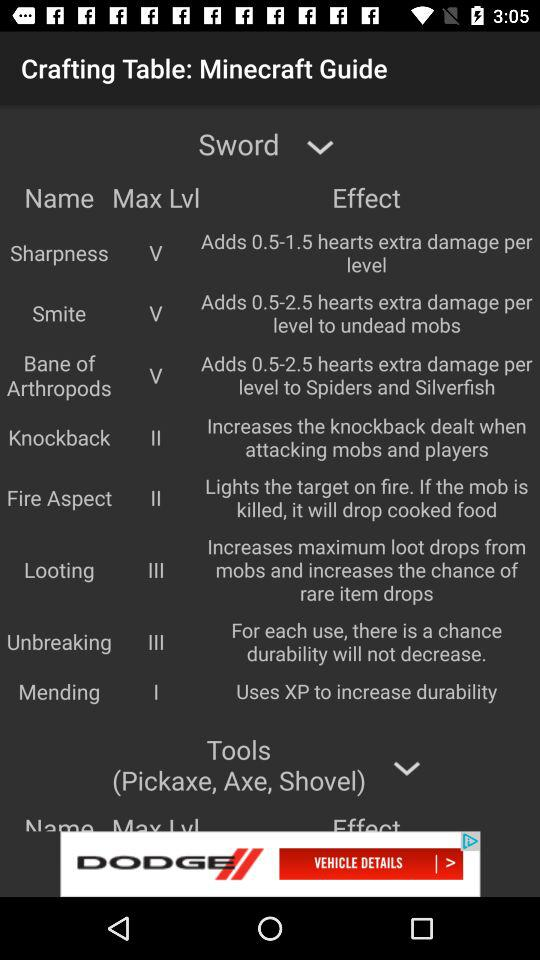What is the fire aspect maximum level? The maximum level is II. 